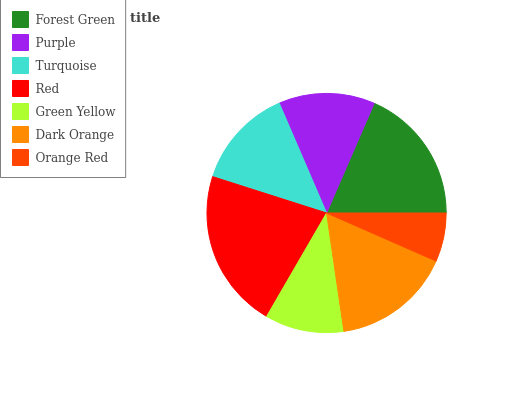Is Orange Red the minimum?
Answer yes or no. Yes. Is Red the maximum?
Answer yes or no. Yes. Is Purple the minimum?
Answer yes or no. No. Is Purple the maximum?
Answer yes or no. No. Is Forest Green greater than Purple?
Answer yes or no. Yes. Is Purple less than Forest Green?
Answer yes or no. Yes. Is Purple greater than Forest Green?
Answer yes or no. No. Is Forest Green less than Purple?
Answer yes or no. No. Is Turquoise the high median?
Answer yes or no. Yes. Is Turquoise the low median?
Answer yes or no. Yes. Is Red the high median?
Answer yes or no. No. Is Forest Green the low median?
Answer yes or no. No. 